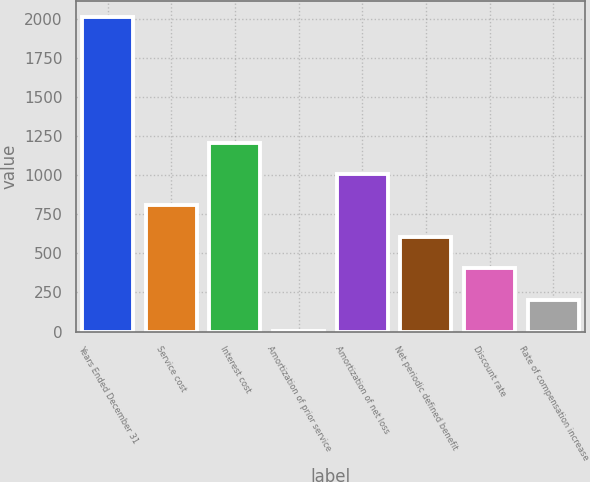Convert chart to OTSL. <chart><loc_0><loc_0><loc_500><loc_500><bar_chart><fcel>Years Ended December 31<fcel>Service cost<fcel>Interest cost<fcel>Amortization of prior service<fcel>Amortization of net loss<fcel>Net periodic defined benefit<fcel>Discount rate<fcel>Rate of compensation increase<nl><fcel>2011<fcel>806.8<fcel>1208.2<fcel>4<fcel>1007.5<fcel>606.1<fcel>405.4<fcel>204.7<nl></chart> 